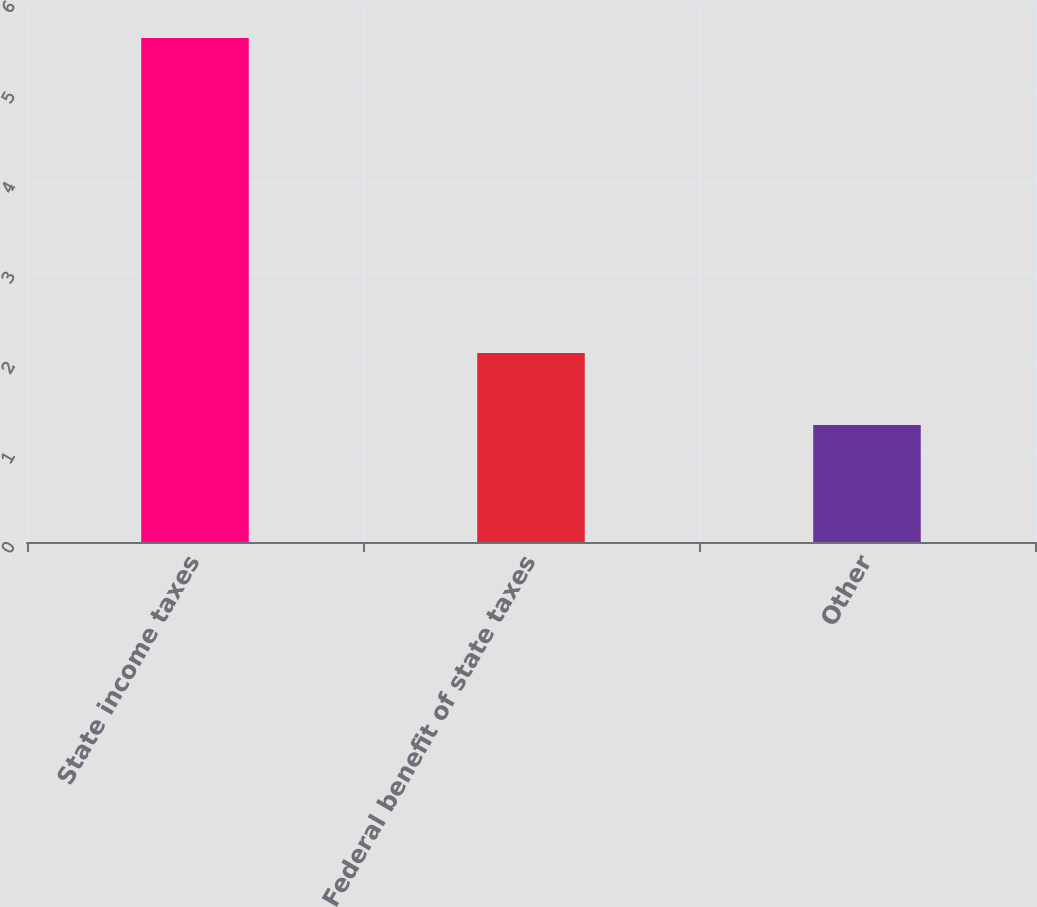<chart> <loc_0><loc_0><loc_500><loc_500><bar_chart><fcel>State income taxes<fcel>Federal benefit of state taxes<fcel>Other<nl><fcel>5.6<fcel>2.1<fcel>1.3<nl></chart> 